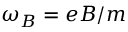<formula> <loc_0><loc_0><loc_500><loc_500>\omega _ { B } = e B / m</formula> 